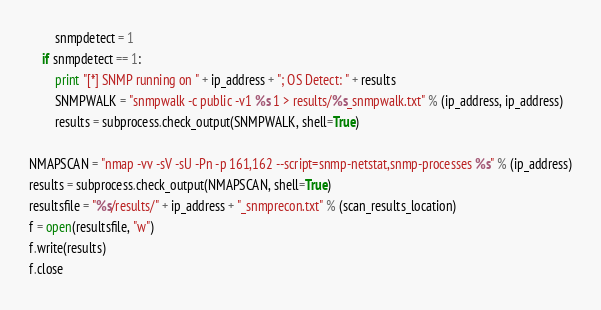Convert code to text. <code><loc_0><loc_0><loc_500><loc_500><_Python_>        snmpdetect = 1
    if snmpdetect == 1:
        print "[*] SNMP running on " + ip_address + "; OS Detect: " + results
        SNMPWALK = "snmpwalk -c public -v1 %s 1 > results/%s_snmpwalk.txt" % (ip_address, ip_address)
        results = subprocess.check_output(SNMPWALK, shell=True)

NMAPSCAN = "nmap -vv -sV -sU -Pn -p 161,162 --script=snmp-netstat,snmp-processes %s" % (ip_address)
results = subprocess.check_output(NMAPSCAN, shell=True)
resultsfile = "%s/results/" + ip_address + "_snmprecon.txt" % (scan_results_location)
f = open(resultsfile, "w")
f.write(results)
f.close
</code> 